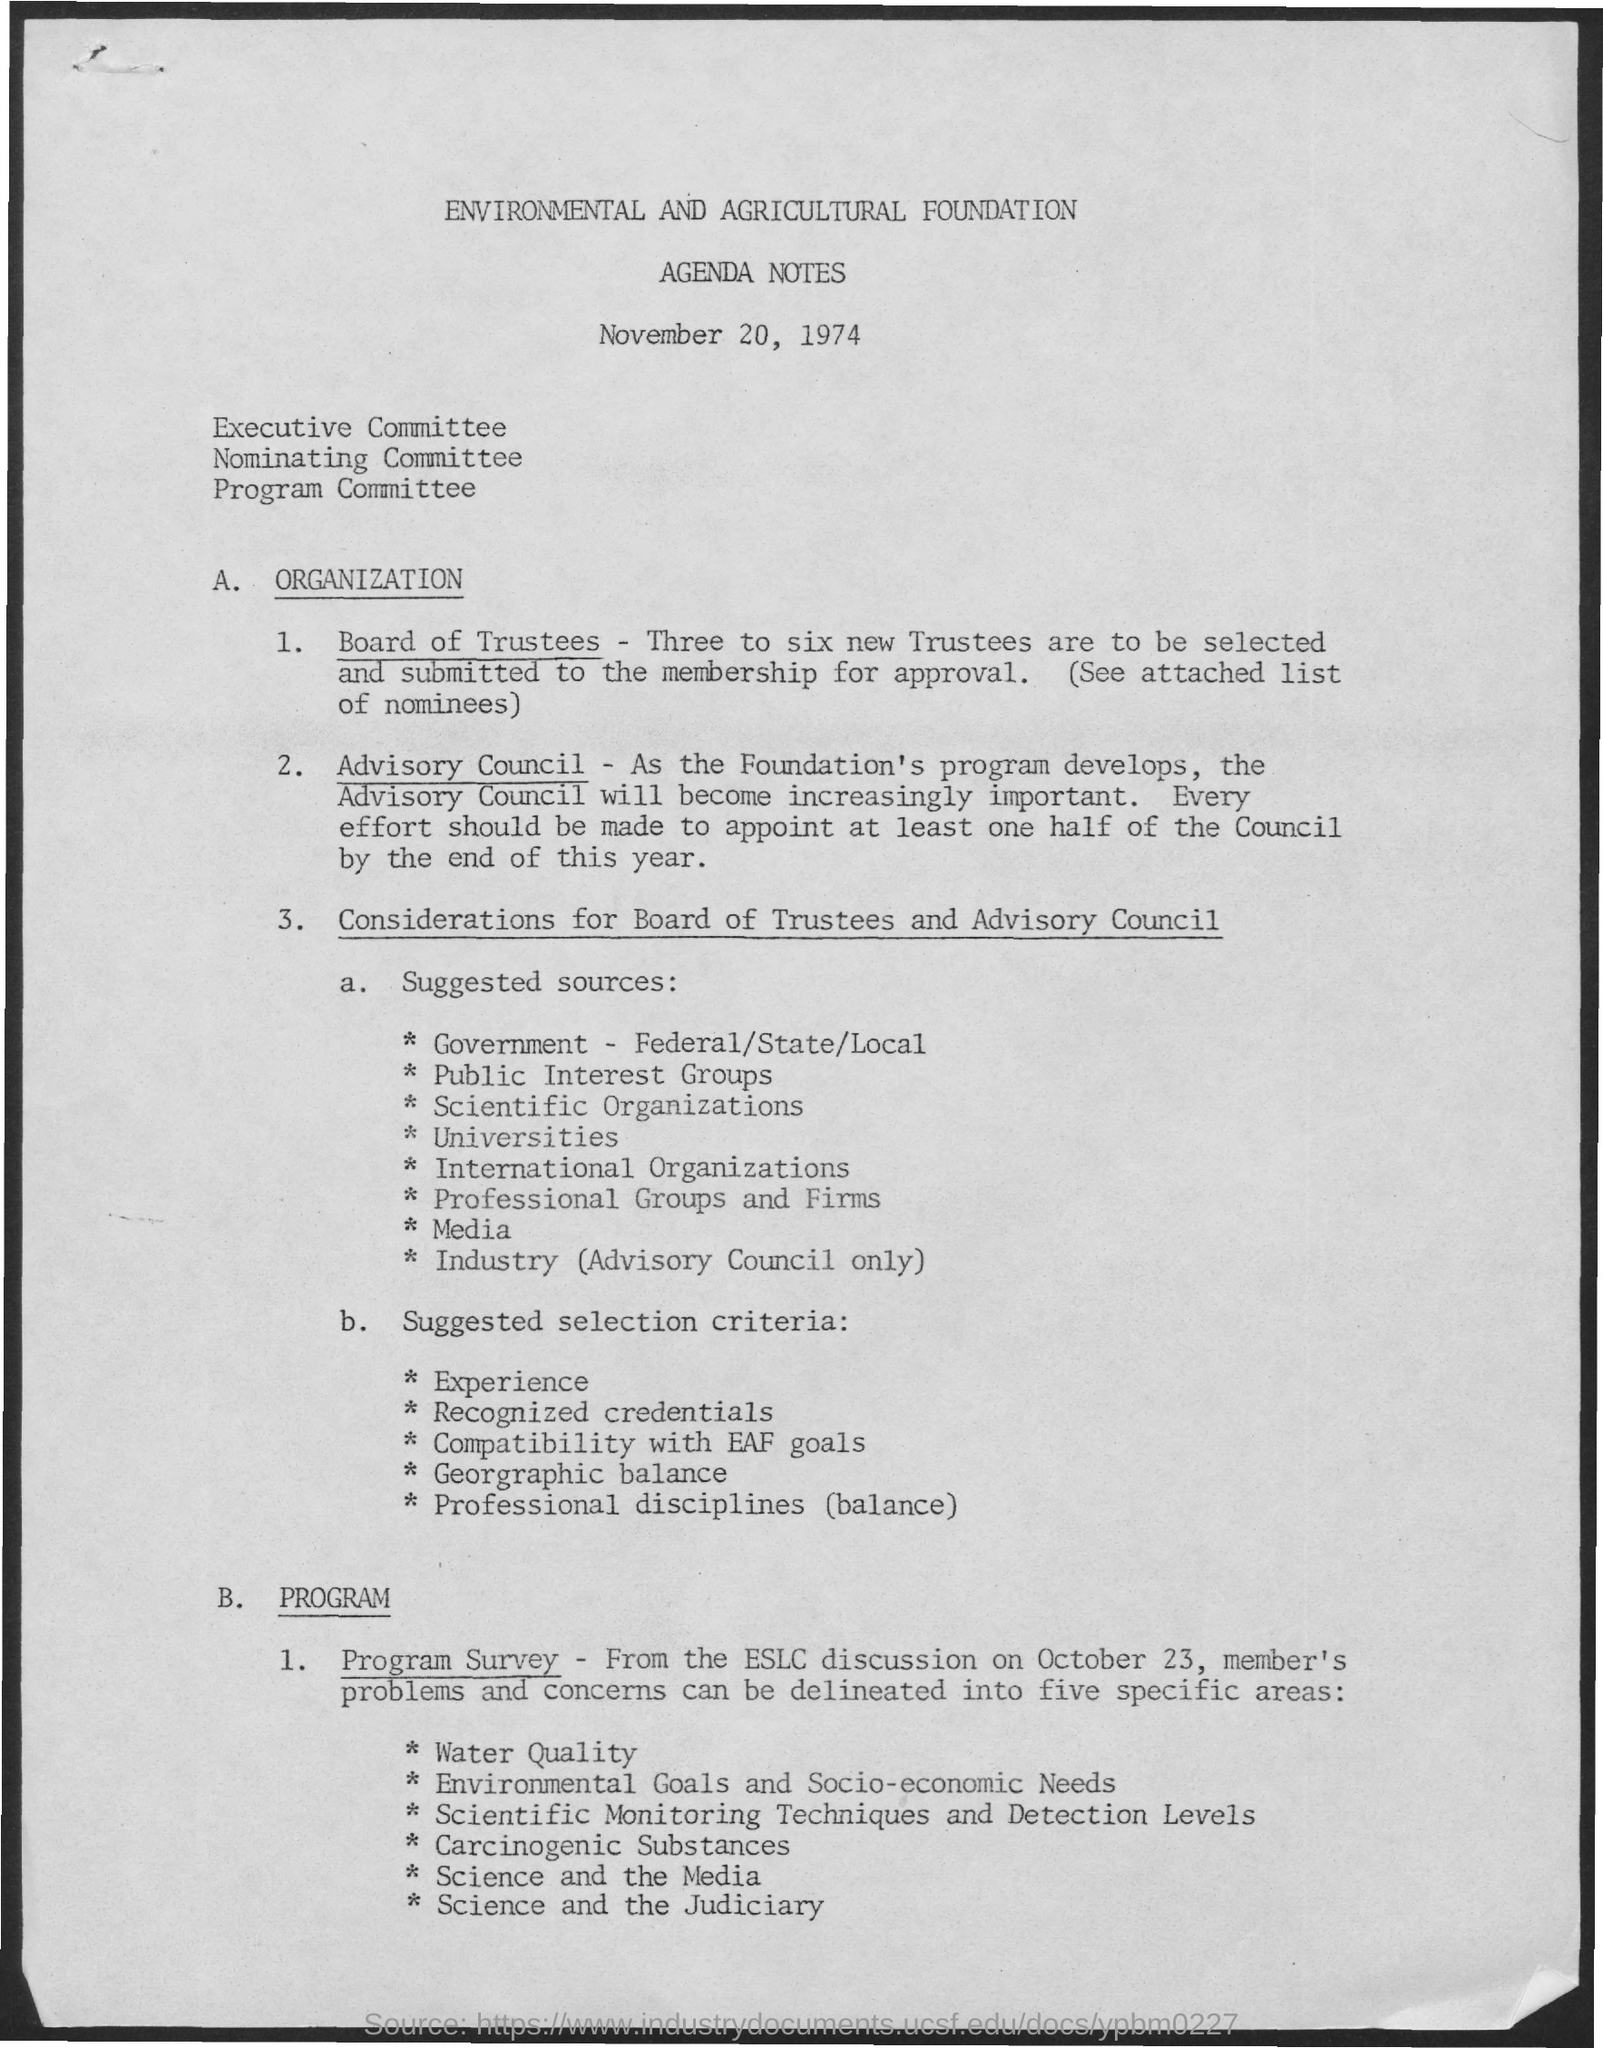What is the second title in the document?
Your response must be concise. AGENDA NOTES. 